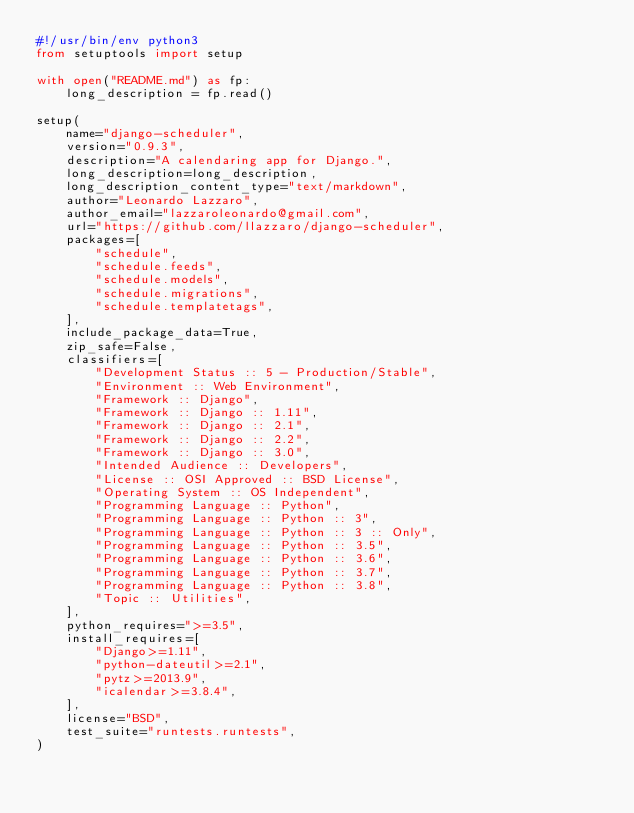<code> <loc_0><loc_0><loc_500><loc_500><_Python_>#!/usr/bin/env python3
from setuptools import setup

with open("README.md") as fp:
    long_description = fp.read()

setup(
    name="django-scheduler",
    version="0.9.3",
    description="A calendaring app for Django.",
    long_description=long_description,
    long_description_content_type="text/markdown",
    author="Leonardo Lazzaro",
    author_email="lazzaroleonardo@gmail.com",
    url="https://github.com/llazzaro/django-scheduler",
    packages=[
        "schedule",
        "schedule.feeds",
        "schedule.models",
        "schedule.migrations",
        "schedule.templatetags",
    ],
    include_package_data=True,
    zip_safe=False,
    classifiers=[
        "Development Status :: 5 - Production/Stable",
        "Environment :: Web Environment",
        "Framework :: Django",
        "Framework :: Django :: 1.11",
        "Framework :: Django :: 2.1",
        "Framework :: Django :: 2.2",
        "Framework :: Django :: 3.0",
        "Intended Audience :: Developers",
        "License :: OSI Approved :: BSD License",
        "Operating System :: OS Independent",
        "Programming Language :: Python",
        "Programming Language :: Python :: 3",
        "Programming Language :: Python :: 3 :: Only",
        "Programming Language :: Python :: 3.5",
        "Programming Language :: Python :: 3.6",
        "Programming Language :: Python :: 3.7",
        "Programming Language :: Python :: 3.8",
        "Topic :: Utilities",
    ],
    python_requires=">=3.5",
    install_requires=[
        "Django>=1.11",
        "python-dateutil>=2.1",
        "pytz>=2013.9",
        "icalendar>=3.8.4",
    ],
    license="BSD",
    test_suite="runtests.runtests",
)
</code> 